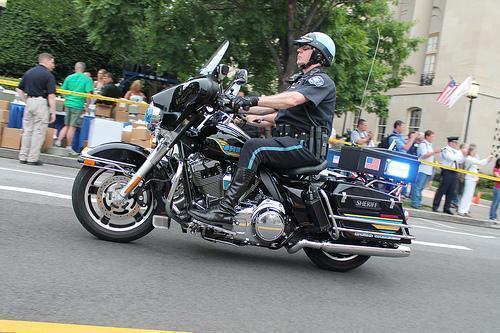How many motorcycles are there?
Give a very brief answer. 1. 